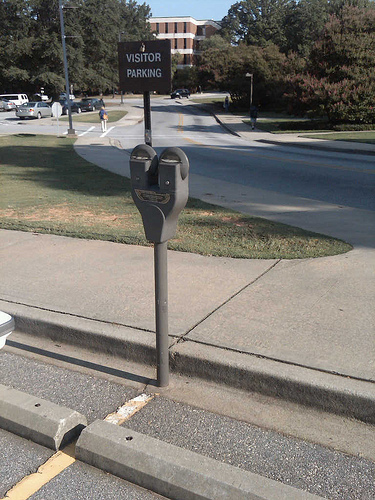Identify the text contained in this image. PARKING VISITOR 